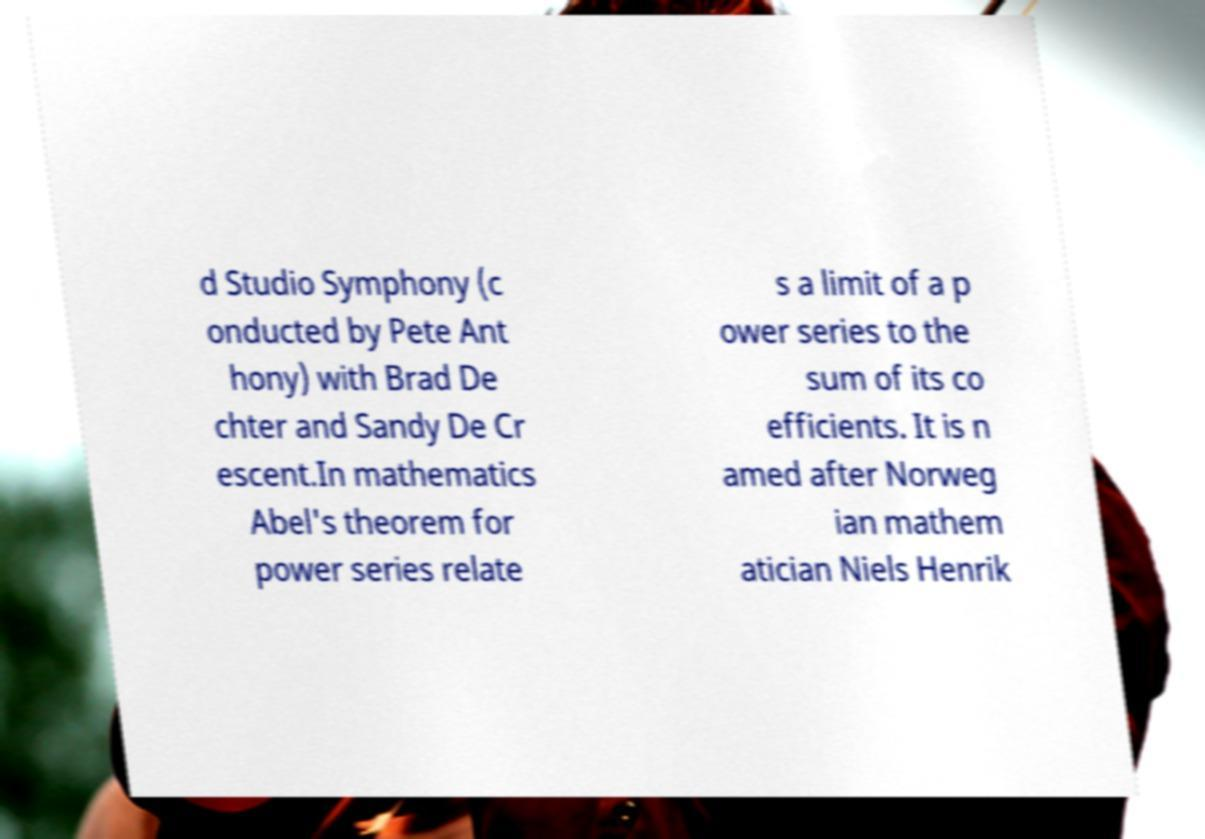For documentation purposes, I need the text within this image transcribed. Could you provide that? d Studio Symphony (c onducted by Pete Ant hony) with Brad De chter and Sandy De Cr escent.In mathematics Abel's theorem for power series relate s a limit of a p ower series to the sum of its co efficients. It is n amed after Norweg ian mathem atician Niels Henrik 